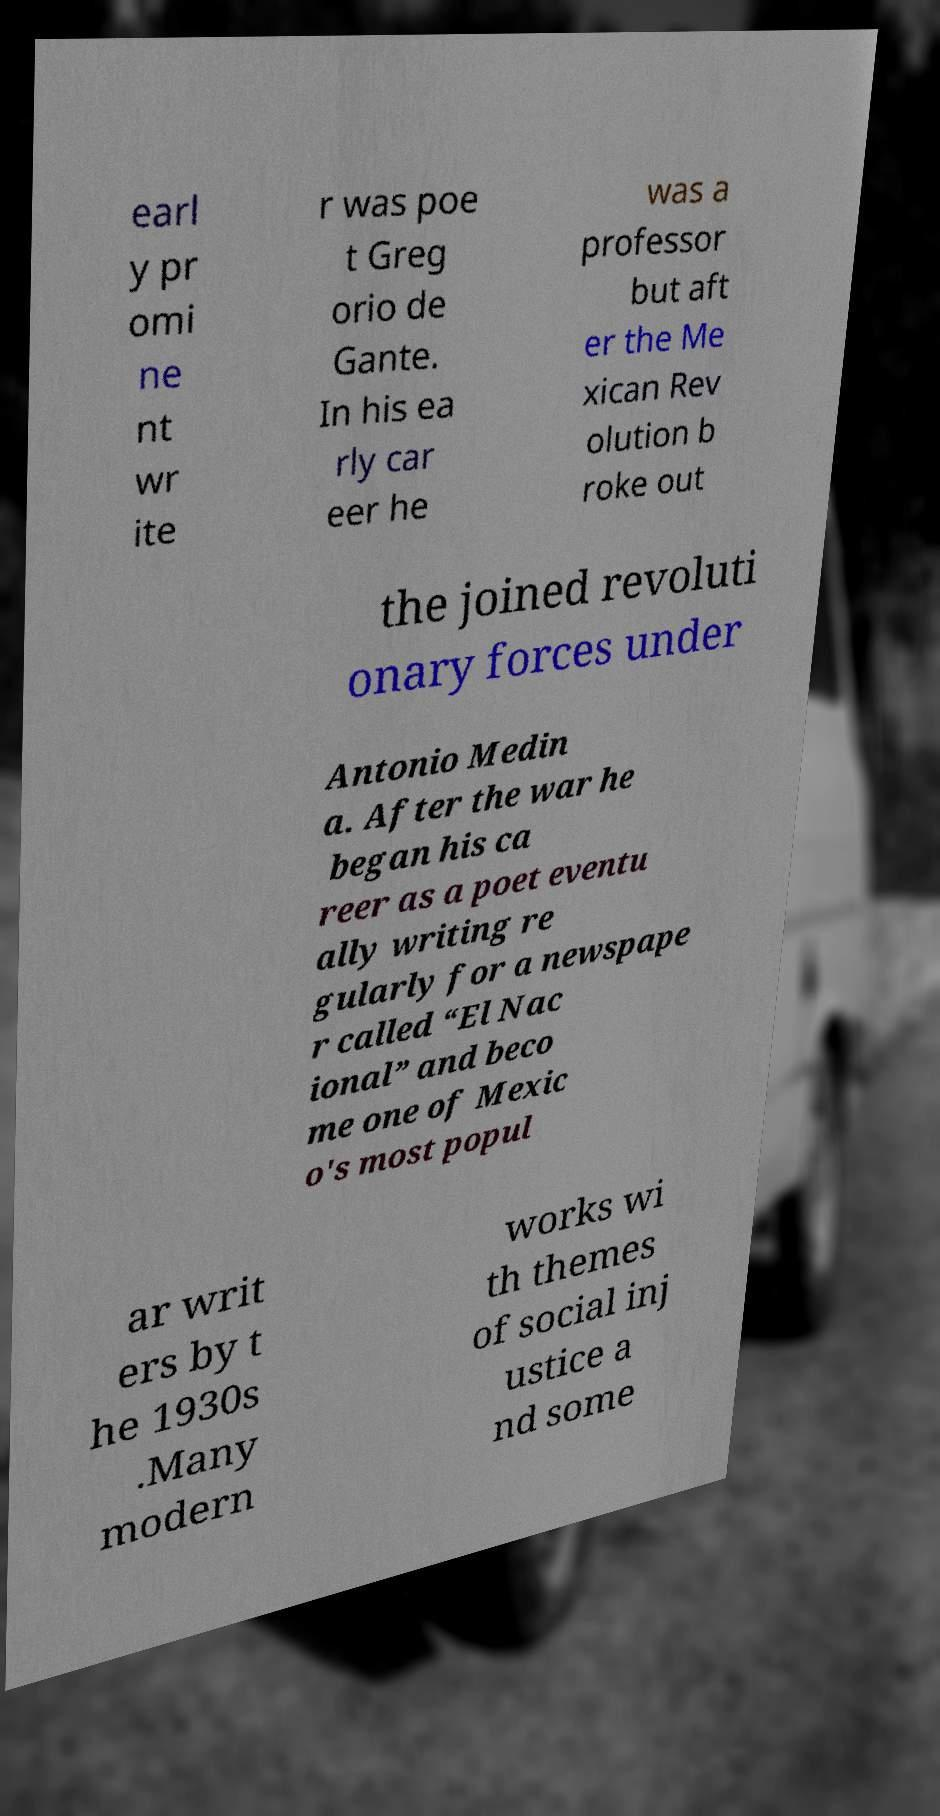I need the written content from this picture converted into text. Can you do that? earl y pr omi ne nt wr ite r was poe t Greg orio de Gante. In his ea rly car eer he was a professor but aft er the Me xican Rev olution b roke out the joined revoluti onary forces under Antonio Medin a. After the war he began his ca reer as a poet eventu ally writing re gularly for a newspape r called “El Nac ional” and beco me one of Mexic o's most popul ar writ ers by t he 1930s .Many modern works wi th themes of social inj ustice a nd some 